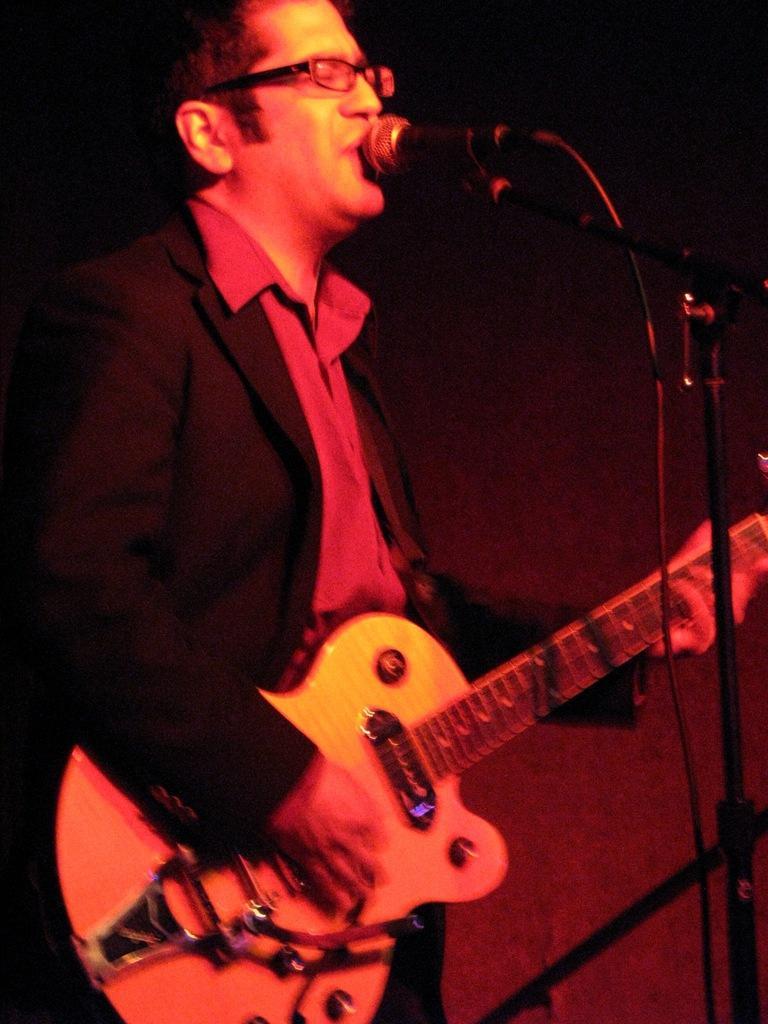Can you describe this image briefly? This picture shows a man playing a guitar and singing with the help of a microphone. 